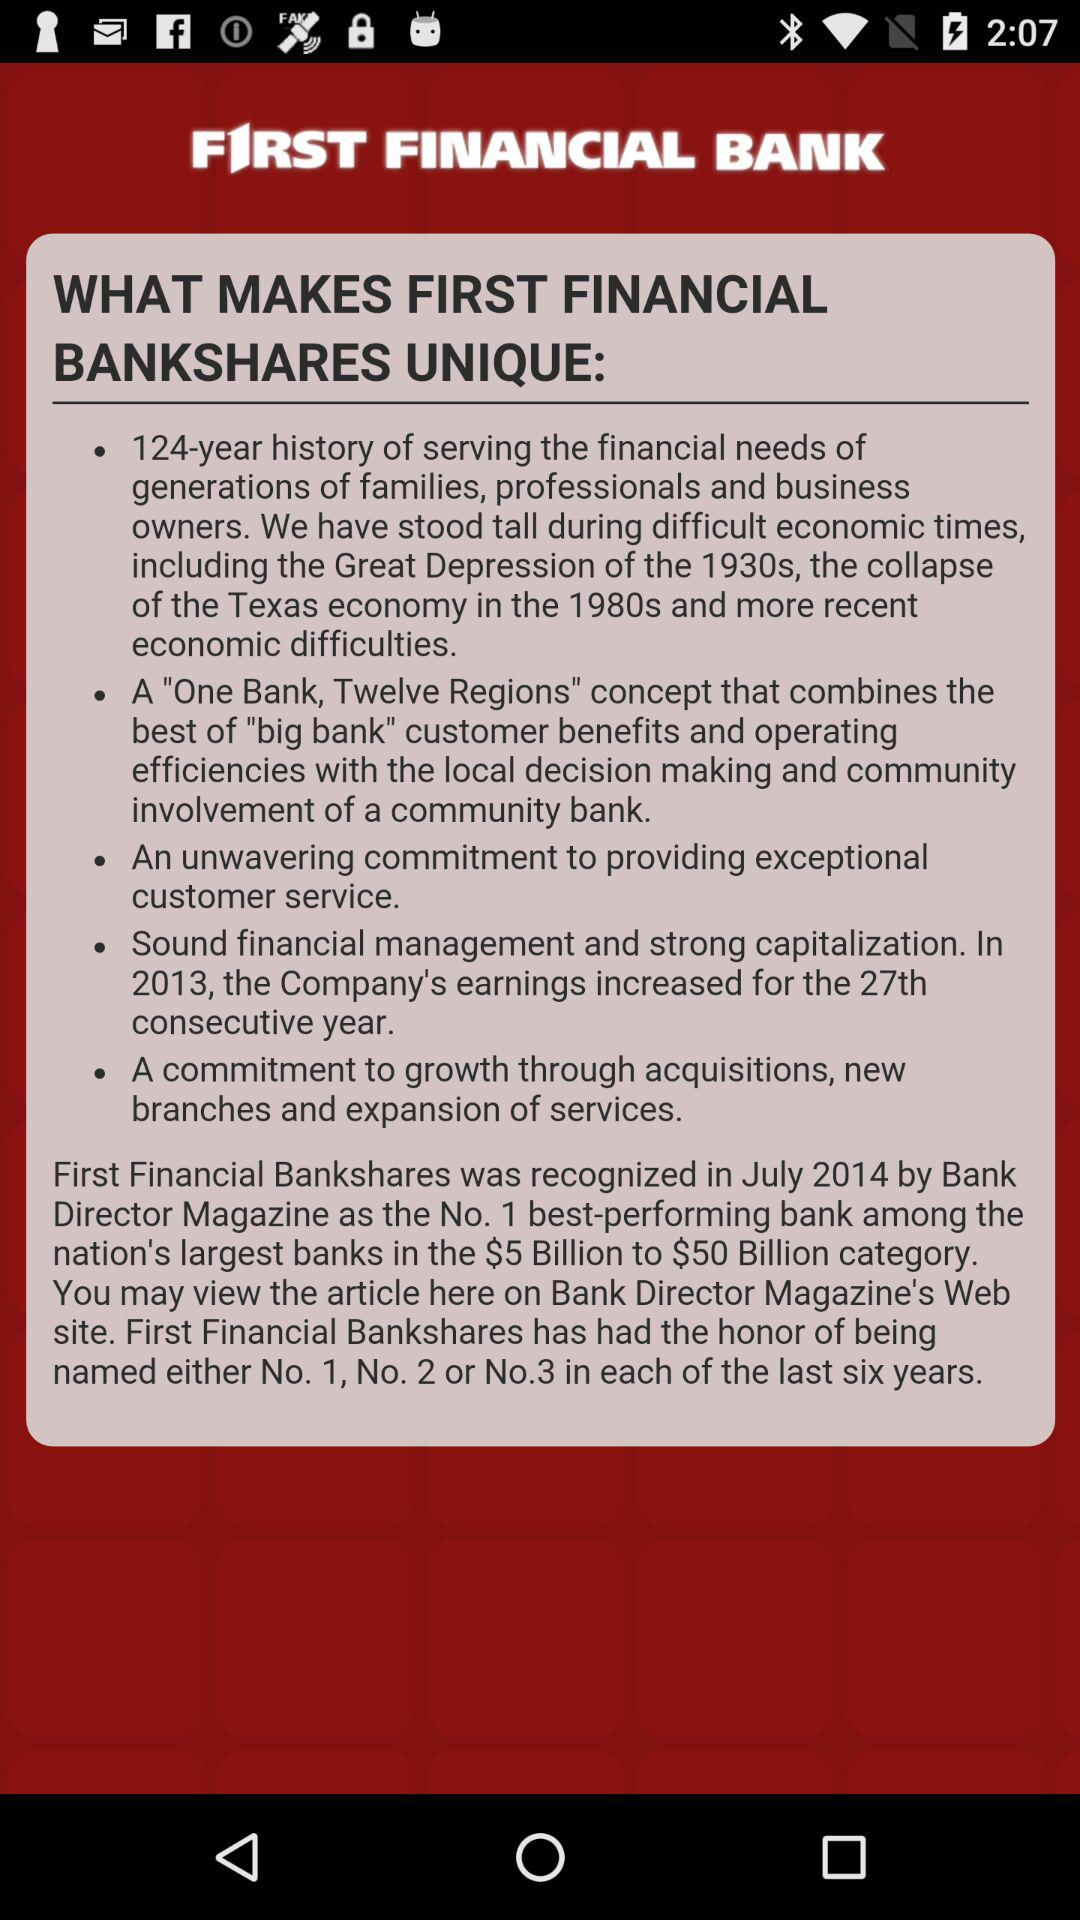What is the title? The title is "WHAT MAKES FIRST FINANCIAL BANKSHARES UNIQUE". 